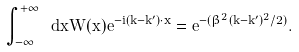Convert formula to latex. <formula><loc_0><loc_0><loc_500><loc_500>\int _ { - \infty } ^ { + \infty } \ d { x } W ( { x } ) e ^ { - i ( { k } - { k } ^ { \prime } ) \cdot { x } } = e ^ { - ( \beta ^ { 2 } ( { k } - { k } ^ { \prime } ) ^ { 2 } / 2 ) } .</formula> 